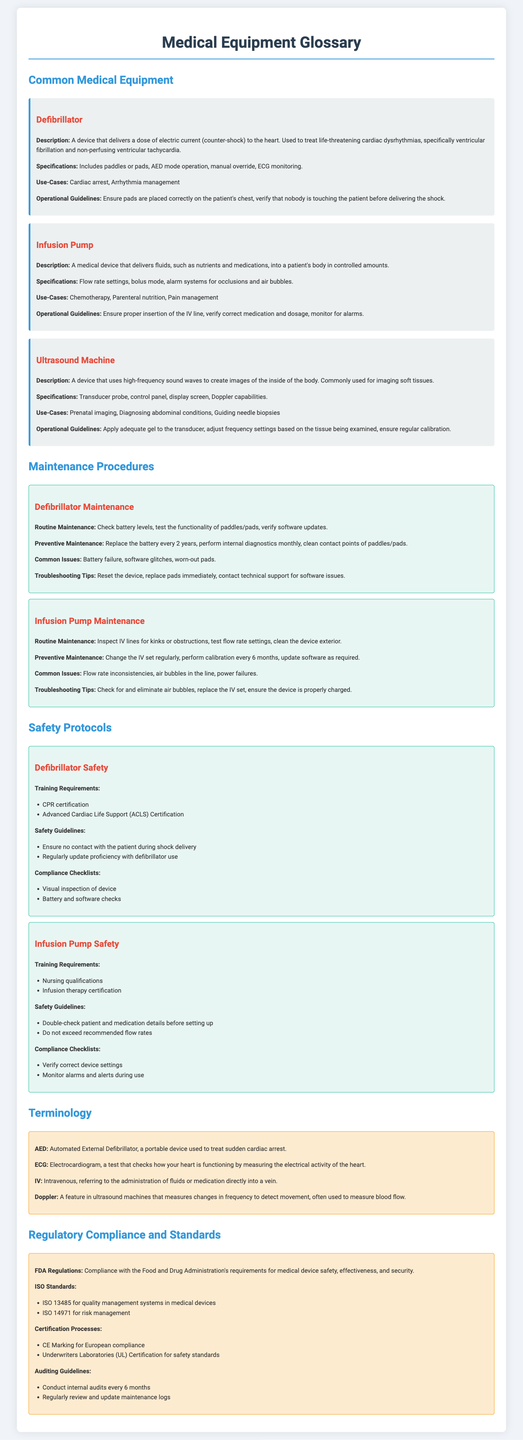what is a defibrillator used for? A defibrillator is used to treat life-threatening cardiac dysrhythmias, specifically ventricular fibrillation and non-perfusing ventricular tachycardia.
Answer: cardiac arrest what is the maintenance frequency for an infusion pump IV set? The maintenance for an infusion pump IV set should be done regularly, but the specific frequency is mentioned as changing the IV set regularly.
Answer: regularly what is one key function of an ultrasound machine? A key function of an ultrasound machine is to create images of the inside of the body using high-frequency sound waves.
Answer: imaging how often should a defibrillator battery be replaced? The document specifies that the defibrillator battery should be replaced every 2 years.
Answer: every 2 years which certification is required for operating a defibrillator? CPR certification is required for operating a defibrillator.
Answer: CPR certification what is a common issue with infusion pumps? A common issue with infusion pumps is flow rate inconsistencies.
Answer: flow rate inconsistencies which ISO standard pertains to risk management? ISO 14971 pertains to risk management.
Answer: ISO 14971 what does AED stand for? AED stands for Automated External Defibrillator.
Answer: Automated External Defibrillator what should be done during a routine defibrillator maintenance? During routine maintenance, check battery levels, test the functionality of paddles/pads, and verify software updates.
Answer: check battery levels 